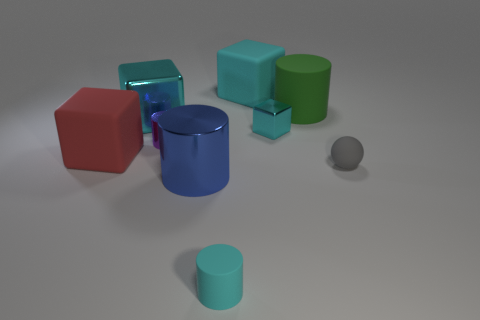How many cyan cubes must be subtracted to get 1 cyan cubes? 2 Subtract all tiny metallic cylinders. How many cylinders are left? 3 Add 1 large cyan metallic blocks. How many objects exist? 10 Subtract all purple cylinders. How many cylinders are left? 3 Subtract all brown balls. How many cyan cubes are left? 3 Subtract 1 blocks. How many blocks are left? 3 Subtract 0 brown cylinders. How many objects are left? 9 Subtract all cylinders. How many objects are left? 5 Subtract all purple spheres. Subtract all green cubes. How many spheres are left? 1 Subtract all rubber cylinders. Subtract all rubber blocks. How many objects are left? 5 